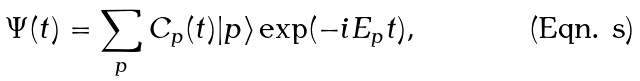Convert formula to latex. <formula><loc_0><loc_0><loc_500><loc_500>\Psi ( t ) = \sum _ { p } C _ { p } ( t ) | p \rangle \exp ( - i E _ { p } t ) ,</formula> 